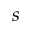Convert formula to latex. <formula><loc_0><loc_0><loc_500><loc_500>s</formula> 